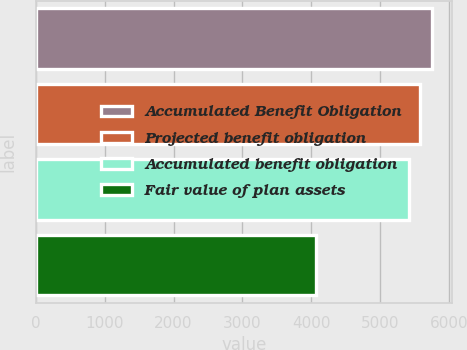<chart> <loc_0><loc_0><loc_500><loc_500><bar_chart><fcel>Accumulated Benefit Obligation<fcel>Projected benefit obligation<fcel>Accumulated benefit obligation<fcel>Fair value of plan assets<nl><fcel>5753.4<fcel>5588.2<fcel>5423<fcel>4072<nl></chart> 